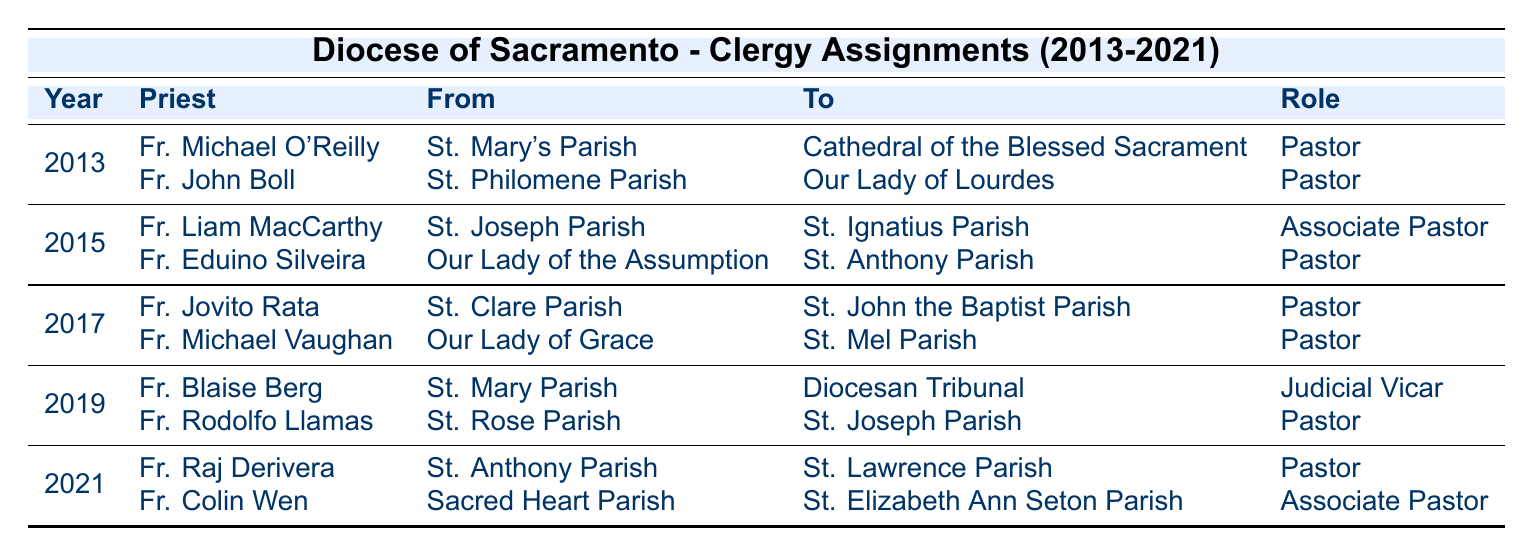What year did Fr. Michael O'Reilly transfer to the Cathedral of the Blessed Sacrament? Fr. Michael O'Reilly's assignment to the Cathedral of the Blessed Sacrament is listed under the year 2013 in the table.
Answer: 2013 How many priests were assigned in the year 2015? The table shows two assignments for 2015, indicating that two priests were assigned that year.
Answer: 2 Which priest transferred from St. Rose Parish? Fr. Rodolfo Llamas is the priest listed as transferring from St. Rose Parish to St. Joseph Parish in the year 2019.
Answer: Fr. Rodolfo Llamas In which year did the highest number of priests make transfers? The table shows that the years 2013, 2015, 2017, 2019, and 2021 each had two assignments, making them all tie for the highest number of transfers within the period.
Answer: 2013, 2015, 2017, 2019, 2021 What role did Fr. Raj Derivera take on after moving to St. Lawrence Parish? Fr. Raj Derivera took on the role of Pastor after transferring to St. Lawrence Parish according to the table.
Answer: Pastor True or False: Fr. Colin Wen moved from St. Elizabeth Ann Seton Parish to Sacred Heart Parish. The table indicates that Fr. Colin Wen moved from Sacred Heart Parish to St. Elizabeth Ann Seton Parish, which makes the statement false.
Answer: False What is the difference in the number of Pastor assignments between 2013 and 2019? In 2013, there were two Pastor assignments (Fr. Michael O'Reilly and Fr. John Boll) and in 2019, there was one Pastor assignment (Fr. Rodolfo Llamas), making the difference one more Pastor assignment in 2013.
Answer: 1 Which parish did Fr. Eduino Silveira come from before moving to St. Anthony Parish? The table indicates that Fr. Eduino Silveira came from Our Lady of the Assumption before moving to St. Anthony Parish in 2015.
Answer: Our Lady of the Assumption How many years did Fr. Jovito Rata serve as a Pastor at St. John the Baptist Parish? There is only one instance in the table listing Fr. Jovito Rata as a Pastor at St. John the Baptist Parish in the year 2017, indicating he served there for that year only.
Answer: 1 Identify the role of Fr. Liam MacCarthy when he moved to St. Ignatius Parish. The table states that Fr. Liam MacCarthy held the title of Associate Pastor when he moved to St. Ignatius Parish in 2015.
Answer: Associate Pastor 